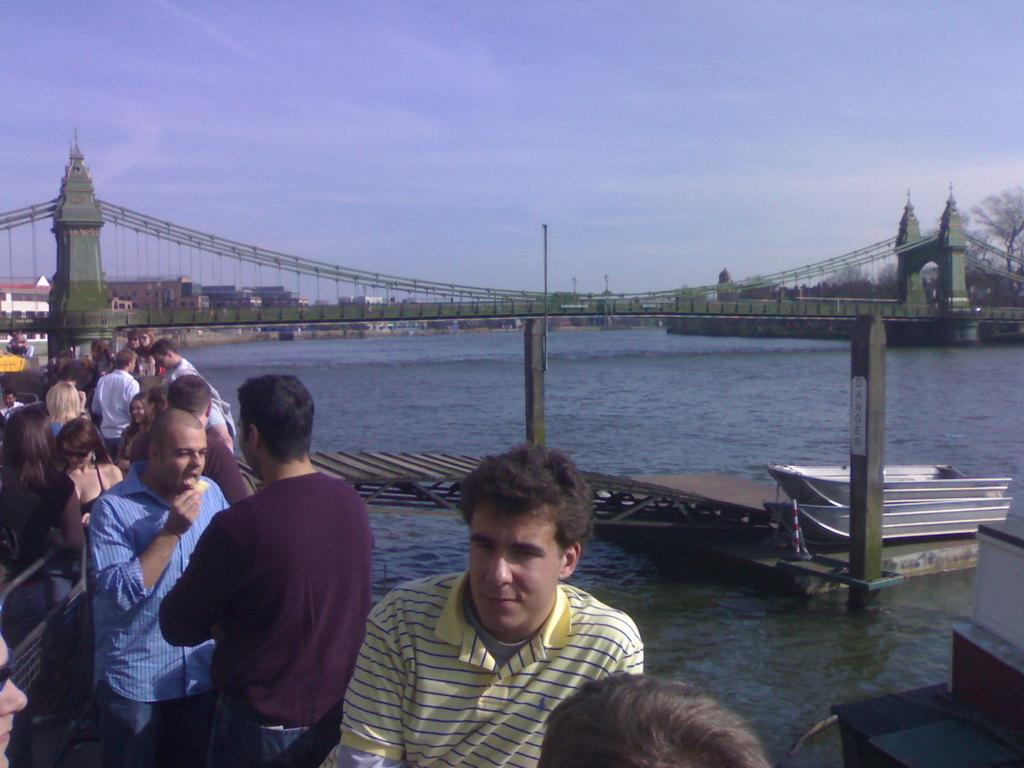Who or what can be seen in the image? There are people in the image. What are the people doing or interacting with in the image? The people are near boats in the image. What structure is present in the image that connects to the water? There is a wooden pier in the image. What is the primary substance visible in the image? There is water visible in the image. What are the poles used for in the image? The poles are likely used for mooring or anchoring the boats. What type of structure connects the land to the water in the image? There is a bridge in the image. What can be seen in the background of the image? There are buildings, trees, and the sky visible in the background of the image. What type of crime is being committed in the image? There is no indication of any crime being committed in the image. What is the title of the image? The image does not have a title, as it is not a piece of artwork or literature. 